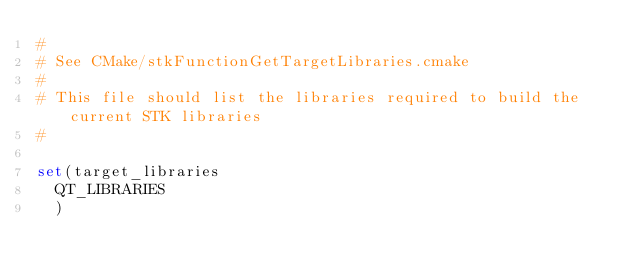<code> <loc_0><loc_0><loc_500><loc_500><_CMake_>#
# See CMake/stkFunctionGetTargetLibraries.cmake
#
# This file should list the libraries required to build the current STK libraries
#

set(target_libraries
  QT_LIBRARIES
  )
</code> 